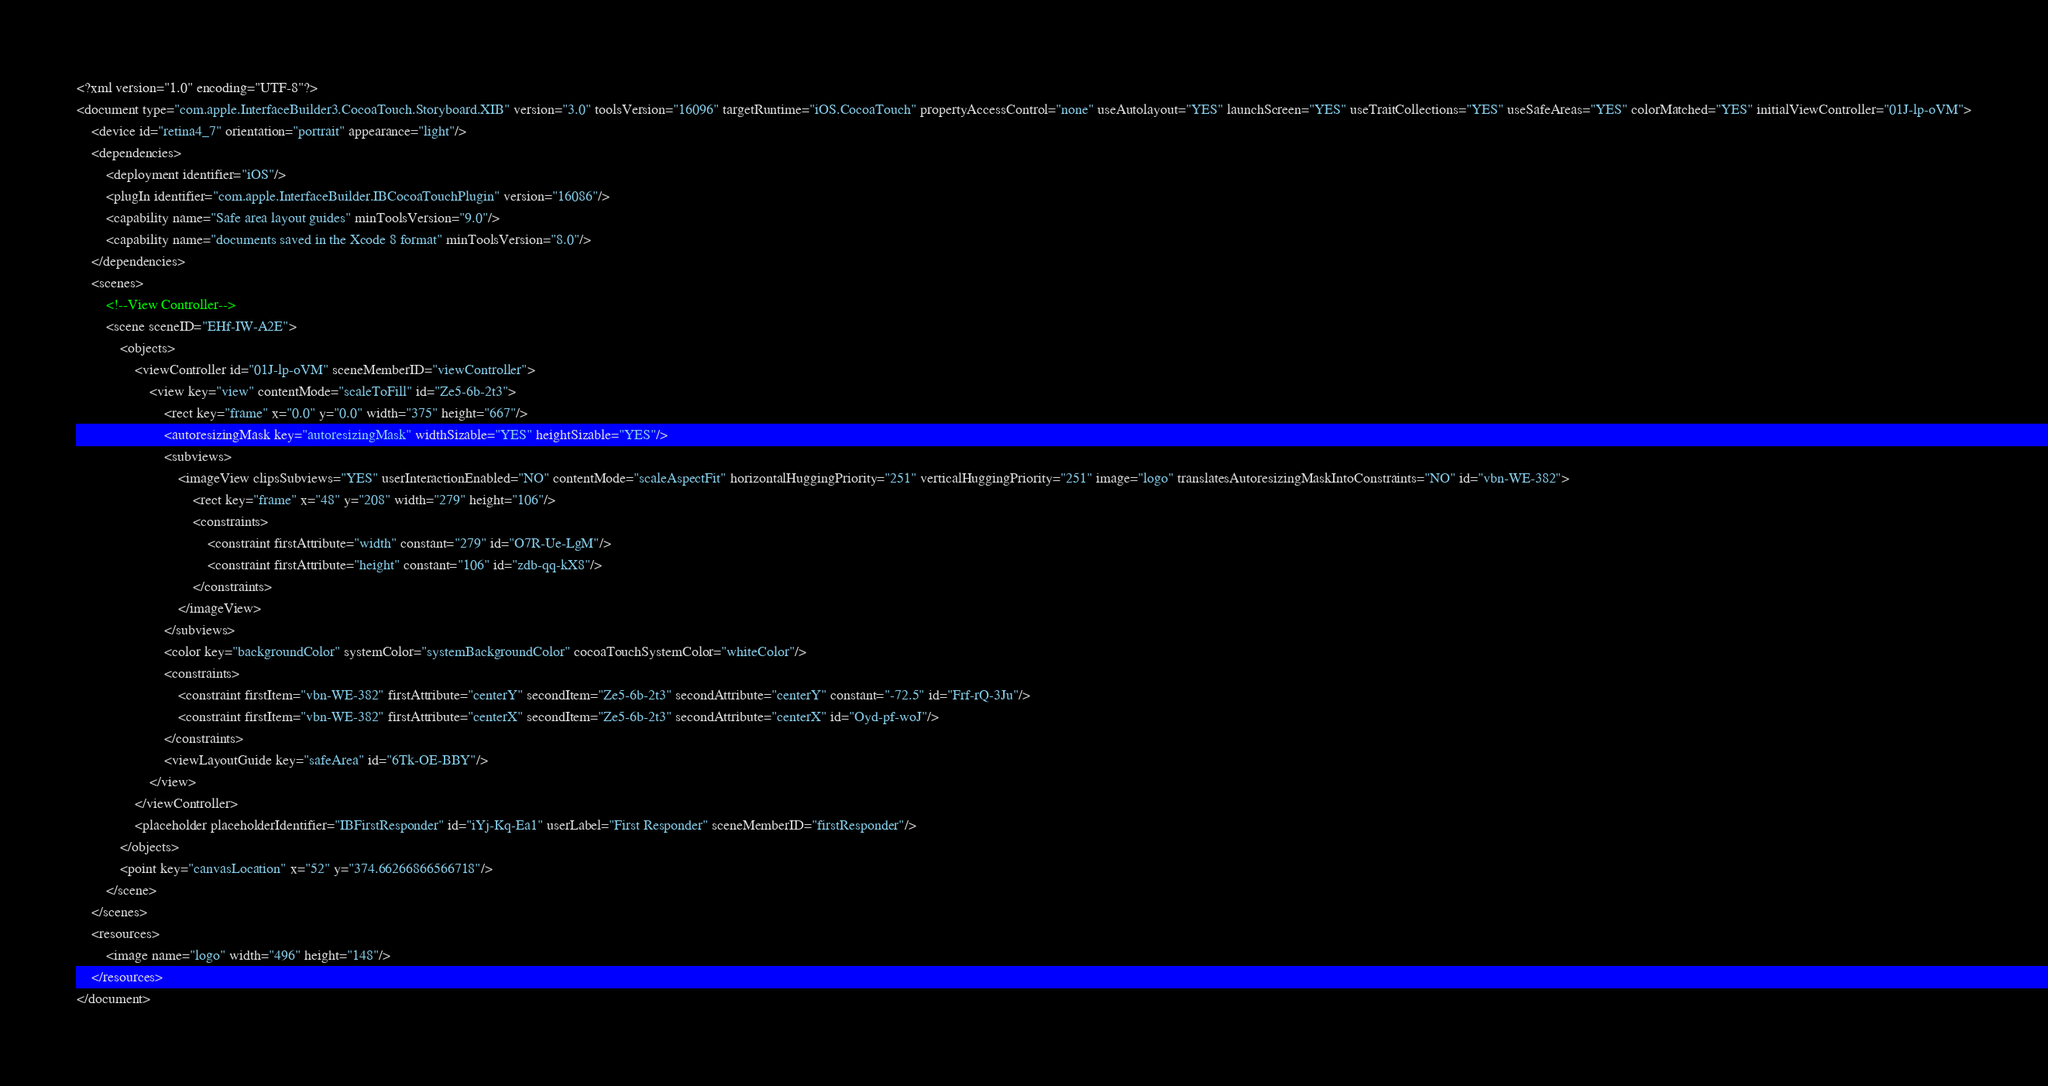<code> <loc_0><loc_0><loc_500><loc_500><_XML_><?xml version="1.0" encoding="UTF-8"?>
<document type="com.apple.InterfaceBuilder3.CocoaTouch.Storyboard.XIB" version="3.0" toolsVersion="16096" targetRuntime="iOS.CocoaTouch" propertyAccessControl="none" useAutolayout="YES" launchScreen="YES" useTraitCollections="YES" useSafeAreas="YES" colorMatched="YES" initialViewController="01J-lp-oVM">
    <device id="retina4_7" orientation="portrait" appearance="light"/>
    <dependencies>
        <deployment identifier="iOS"/>
        <plugIn identifier="com.apple.InterfaceBuilder.IBCocoaTouchPlugin" version="16086"/>
        <capability name="Safe area layout guides" minToolsVersion="9.0"/>
        <capability name="documents saved in the Xcode 8 format" minToolsVersion="8.0"/>
    </dependencies>
    <scenes>
        <!--View Controller-->
        <scene sceneID="EHf-IW-A2E">
            <objects>
                <viewController id="01J-lp-oVM" sceneMemberID="viewController">
                    <view key="view" contentMode="scaleToFill" id="Ze5-6b-2t3">
                        <rect key="frame" x="0.0" y="0.0" width="375" height="667"/>
                        <autoresizingMask key="autoresizingMask" widthSizable="YES" heightSizable="YES"/>
                        <subviews>
                            <imageView clipsSubviews="YES" userInteractionEnabled="NO" contentMode="scaleAspectFit" horizontalHuggingPriority="251" verticalHuggingPriority="251" image="logo" translatesAutoresizingMaskIntoConstraints="NO" id="vbn-WE-382">
                                <rect key="frame" x="48" y="208" width="279" height="106"/>
                                <constraints>
                                    <constraint firstAttribute="width" constant="279" id="O7R-Ue-LgM"/>
                                    <constraint firstAttribute="height" constant="106" id="zdb-qq-kX8"/>
                                </constraints>
                            </imageView>
                        </subviews>
                        <color key="backgroundColor" systemColor="systemBackgroundColor" cocoaTouchSystemColor="whiteColor"/>
                        <constraints>
                            <constraint firstItem="vbn-WE-382" firstAttribute="centerY" secondItem="Ze5-6b-2t3" secondAttribute="centerY" constant="-72.5" id="Frf-rQ-3Ju"/>
                            <constraint firstItem="vbn-WE-382" firstAttribute="centerX" secondItem="Ze5-6b-2t3" secondAttribute="centerX" id="Oyd-pf-woJ"/>
                        </constraints>
                        <viewLayoutGuide key="safeArea" id="6Tk-OE-BBY"/>
                    </view>
                </viewController>
                <placeholder placeholderIdentifier="IBFirstResponder" id="iYj-Kq-Ea1" userLabel="First Responder" sceneMemberID="firstResponder"/>
            </objects>
            <point key="canvasLocation" x="52" y="374.66266866566718"/>
        </scene>
    </scenes>
    <resources>
        <image name="logo" width="496" height="148"/>
    </resources>
</document>
</code> 